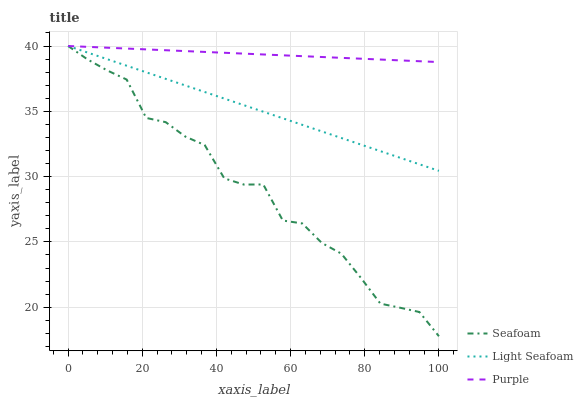Does Seafoam have the minimum area under the curve?
Answer yes or no. Yes. Does Purple have the maximum area under the curve?
Answer yes or no. Yes. Does Light Seafoam have the minimum area under the curve?
Answer yes or no. No. Does Light Seafoam have the maximum area under the curve?
Answer yes or no. No. Is Light Seafoam the smoothest?
Answer yes or no. Yes. Is Seafoam the roughest?
Answer yes or no. Yes. Is Seafoam the smoothest?
Answer yes or no. No. Is Light Seafoam the roughest?
Answer yes or no. No. Does Light Seafoam have the lowest value?
Answer yes or no. No. Does Seafoam have the highest value?
Answer yes or no. Yes. Does Light Seafoam intersect Seafoam?
Answer yes or no. Yes. Is Light Seafoam less than Seafoam?
Answer yes or no. No. Is Light Seafoam greater than Seafoam?
Answer yes or no. No. 